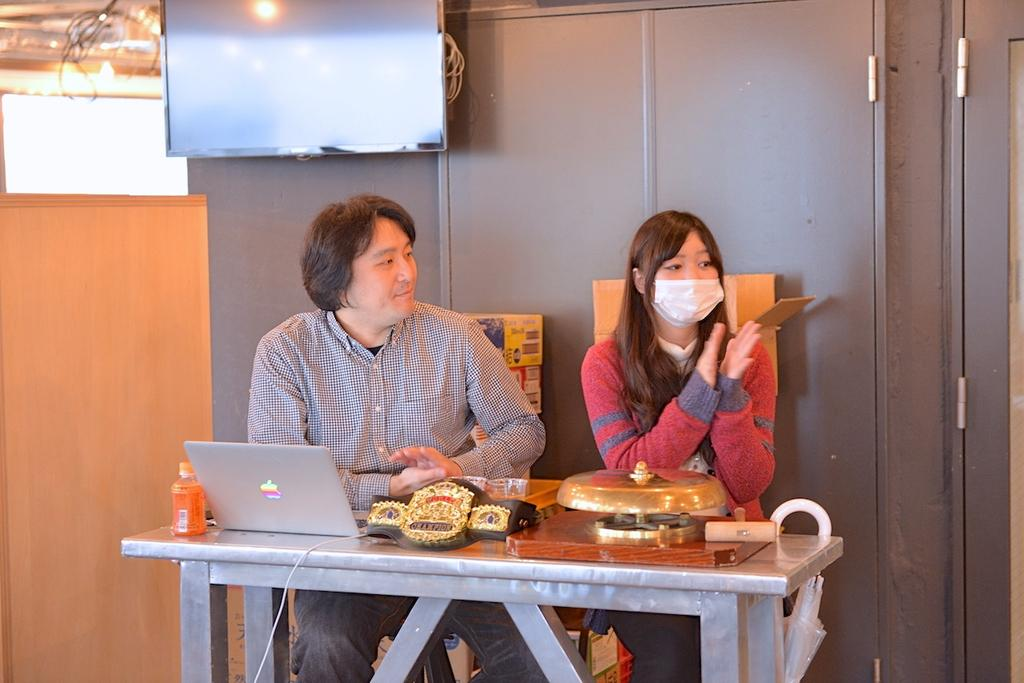Who is present in the image? There is a man and a woman in the image. What are the man and woman doing in the image? Both the man and woman are sitting on chairs. What objects can be seen on the table in the image? There is a laptop and a bottle on the table. What can be seen in the background of the image? There is a television in the background. What type of fog can be seen in the image? There is no fog present in the image. Can you describe the man's reaction to the woman's crush in the image? There is no mention of a crush or any romantic relationship between the man and woman in the image. 